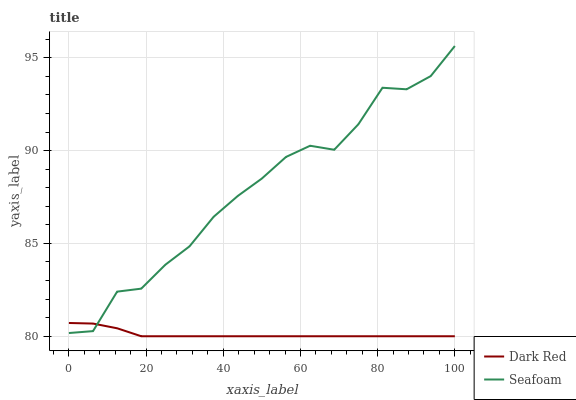Does Seafoam have the minimum area under the curve?
Answer yes or no. No. Is Seafoam the smoothest?
Answer yes or no. No. Does Seafoam have the lowest value?
Answer yes or no. No. 